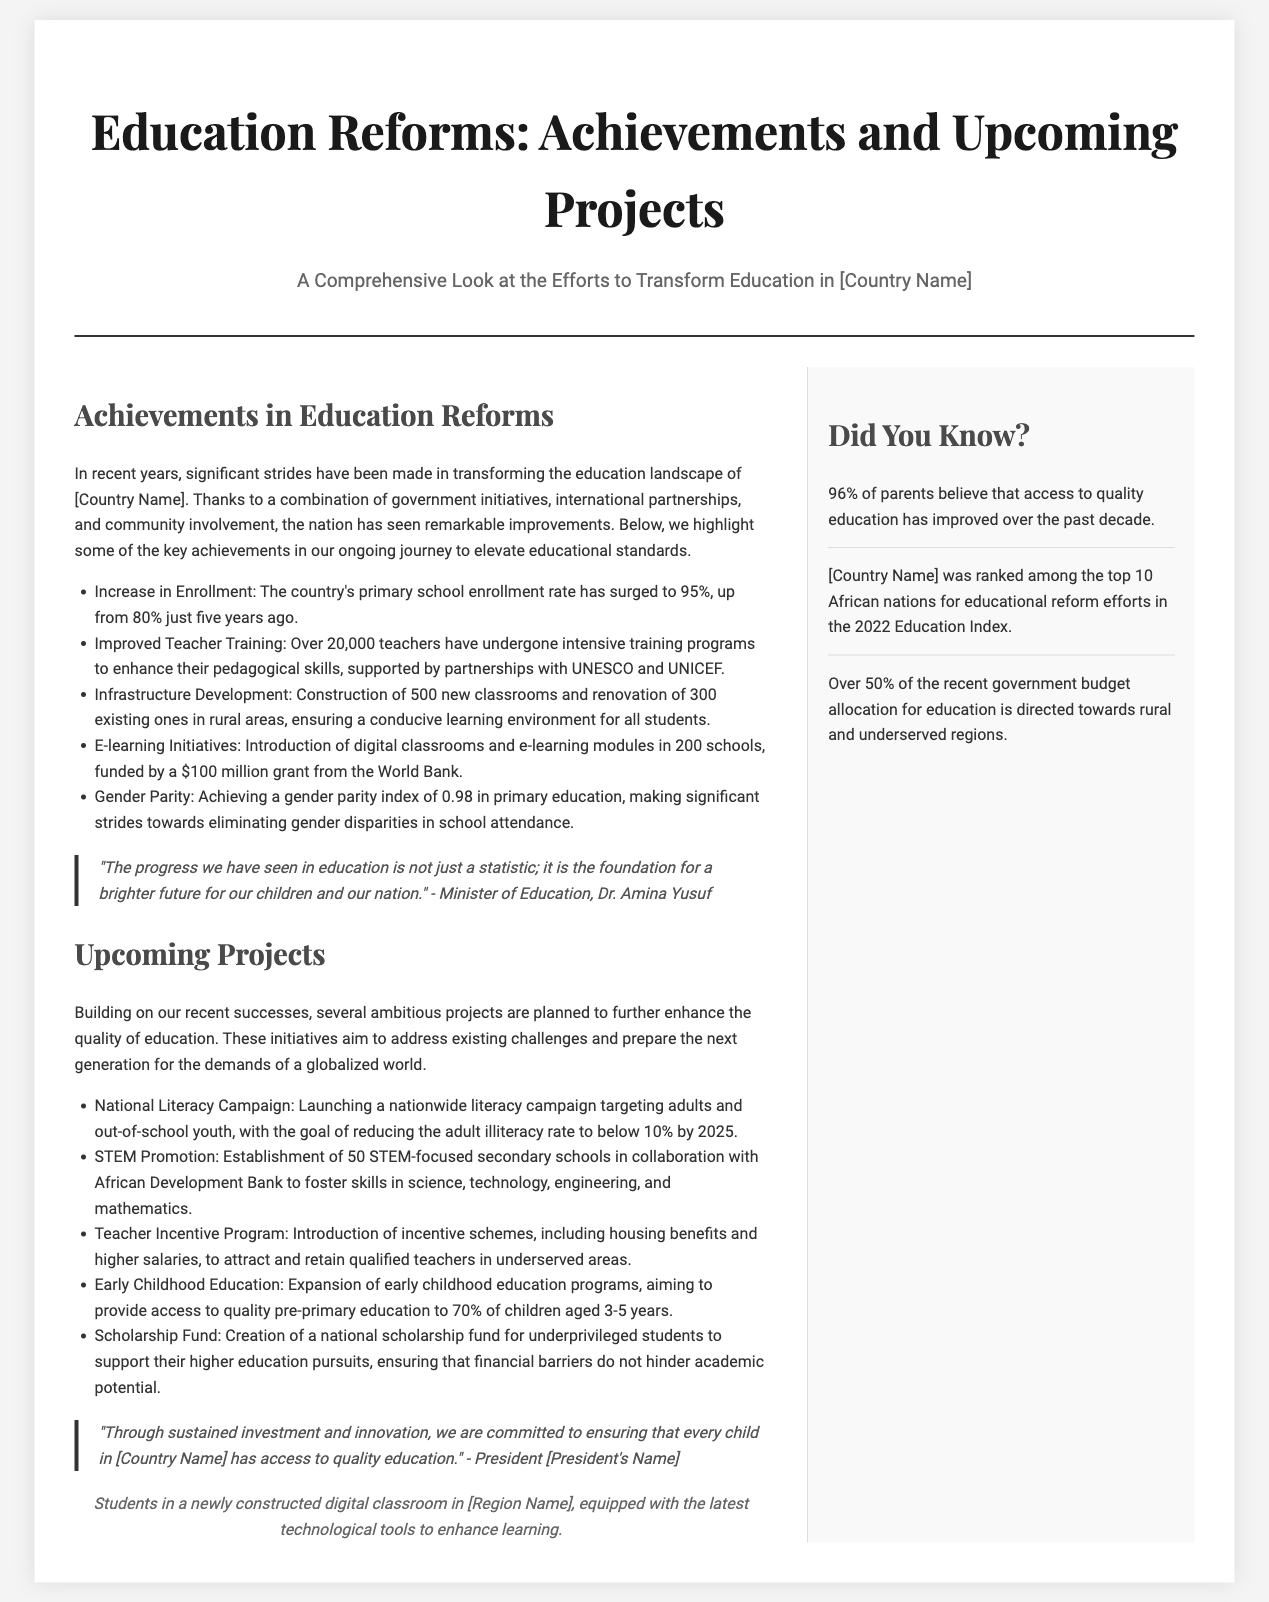What is the primary school enrollment rate? The primary school enrollment rate has surged to 95%, up from 80% just five years ago.
Answer: 95% How many teachers have undergone training programs? Over 20,000 teachers have undergone intensive training programs to enhance their pedagogical skills.
Answer: 20,000 What is the goal for the adult illiteracy rate by 2025? The goal is to reduce the adult illiteracy rate to below 10% by 2025.
Answer: Below 10% Who is the Minister of Education? The Minister of Education is Dr. Amina Yusuf.
Answer: Dr. Amina Yusuf How many new classrooms have been constructed? The construction of 500 new classrooms has been completed.
Answer: 500 What initiative targets children aged 3-5 years? The initiative expanding early childhood education programs aims to provide access to quality pre-primary education.
Answer: Early childhood education programs What was the funding amount for e-learning initiatives? The funding amount for e-learning initiatives is $100 million.
Answer: $100 million What percentage of recent government budget allocation for education is directed towards rural areas? Over 50% of the recent government budget allocation for education is directed towards rural and underserved regions.
Answer: Over 50% What cooperation is mentioned for establishing STEM-focused secondary schools? The collaboration for establishing STEM-focused secondary schools is with the African Development Bank.
Answer: African Development Bank 